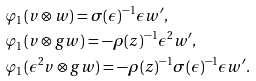Convert formula to latex. <formula><loc_0><loc_0><loc_500><loc_500>& \varphi _ { 1 } ( v \otimes w ) = \sigma ( \epsilon ) ^ { - 1 } \epsilon w ^ { \prime } , \\ & \varphi _ { 1 } ( v \otimes g w ) = - \rho ( z ) ^ { - 1 } \epsilon ^ { 2 } w ^ { \prime } , \\ & \varphi _ { 1 } ( \epsilon ^ { 2 } v \otimes g w ) = - \rho ( z ) ^ { - 1 } \sigma ( \epsilon ) ^ { - 1 } \epsilon w ^ { \prime } .</formula> 